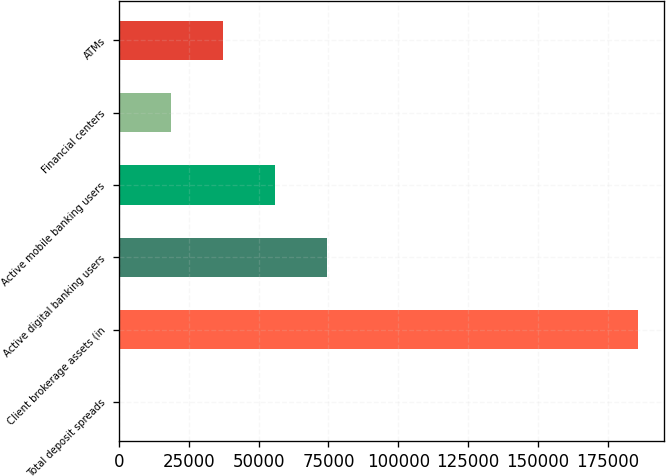Convert chart. <chart><loc_0><loc_0><loc_500><loc_500><bar_chart><fcel>Total deposit spreads<fcel>Client brokerage assets (in<fcel>Active digital banking users<fcel>Active mobile banking users<fcel>Financial centers<fcel>ATMs<nl><fcel>2.14<fcel>185881<fcel>74353.7<fcel>55765.8<fcel>18590<fcel>37177.9<nl></chart> 